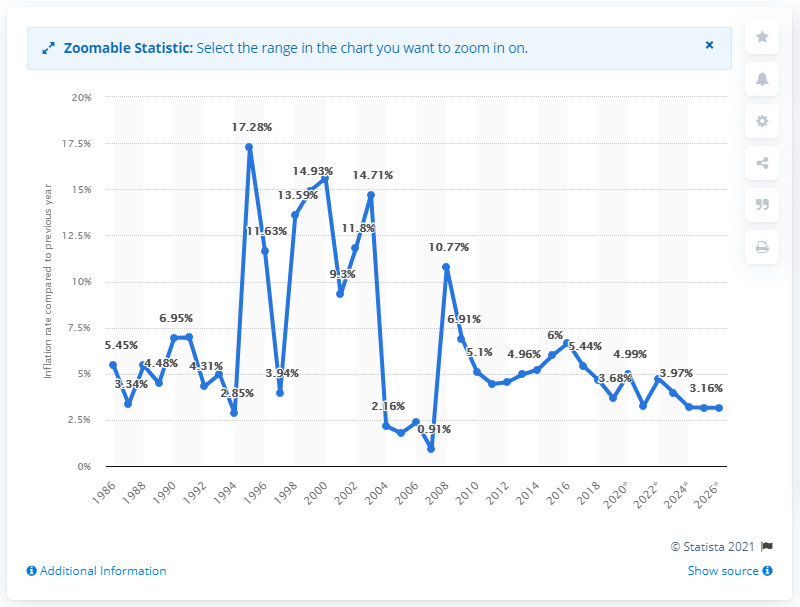List a handful of essential elements in this visual. In 2020, the inflation rate in Papua New Guinea was 4.99%. 